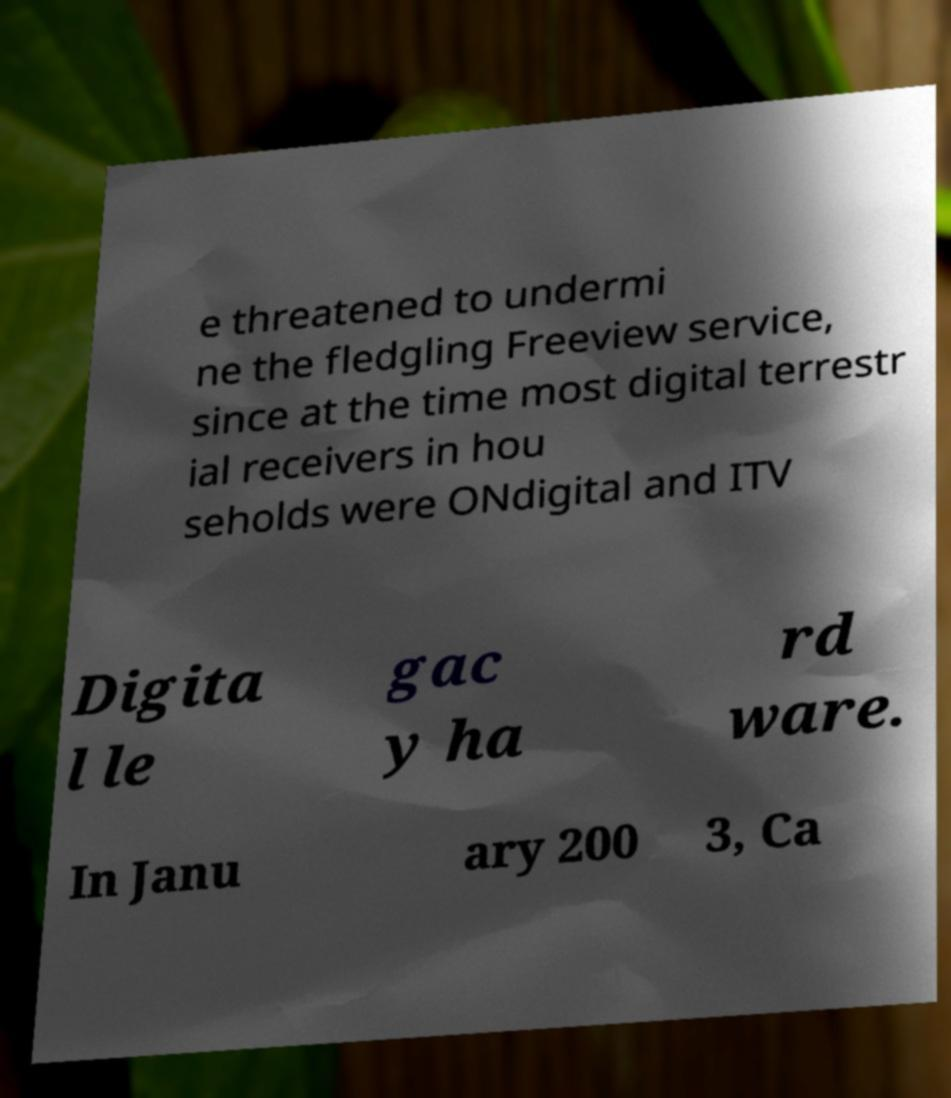For documentation purposes, I need the text within this image transcribed. Could you provide that? e threatened to undermi ne the fledgling Freeview service, since at the time most digital terrestr ial receivers in hou seholds were ONdigital and ITV Digita l le gac y ha rd ware. In Janu ary 200 3, Ca 